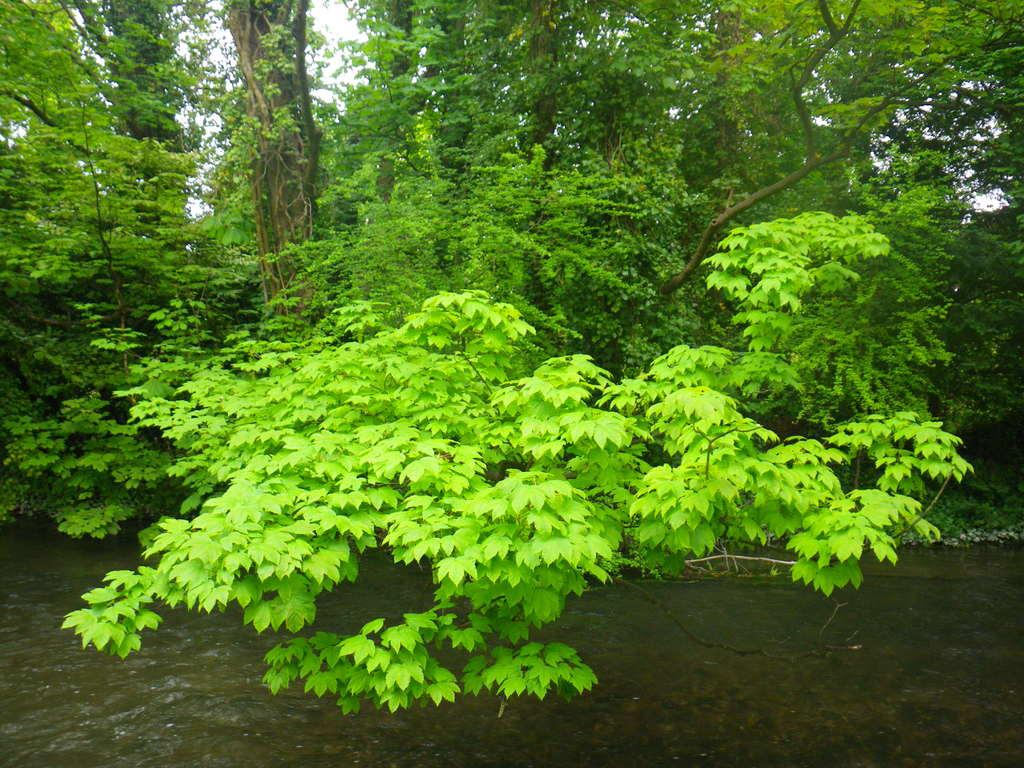What type of vegetation can be seen in the image? There are trees in the image. What natural element is visible alongside the trees? There is water visible in the image. What part of the natural environment is visible in the image? The sky is visible in the image. Where is the basin located in the image? There is no basin present in the image. What type of cellar can be seen in the image? There is no cellar present in the image. 